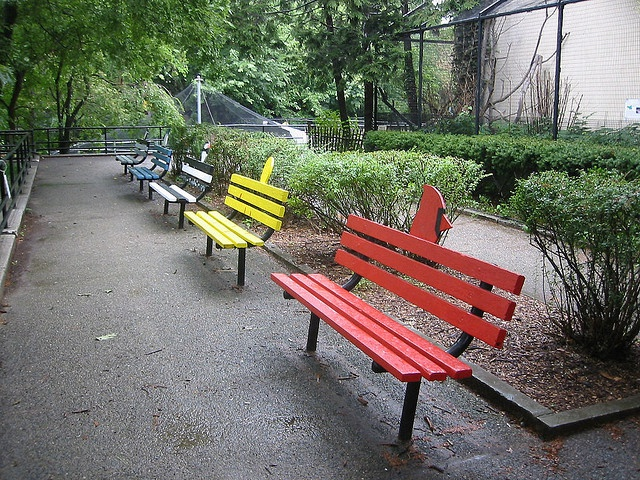Describe the objects in this image and their specific colors. I can see bench in darkgreen, brown, black, lightpink, and salmon tones, bench in darkgreen, yellow, lightyellow, and black tones, bench in darkgreen, black, white, gray, and darkgray tones, bench in darkgreen, black, blue, and gray tones, and bench in darkgreen, black, gray, and darkgray tones in this image. 